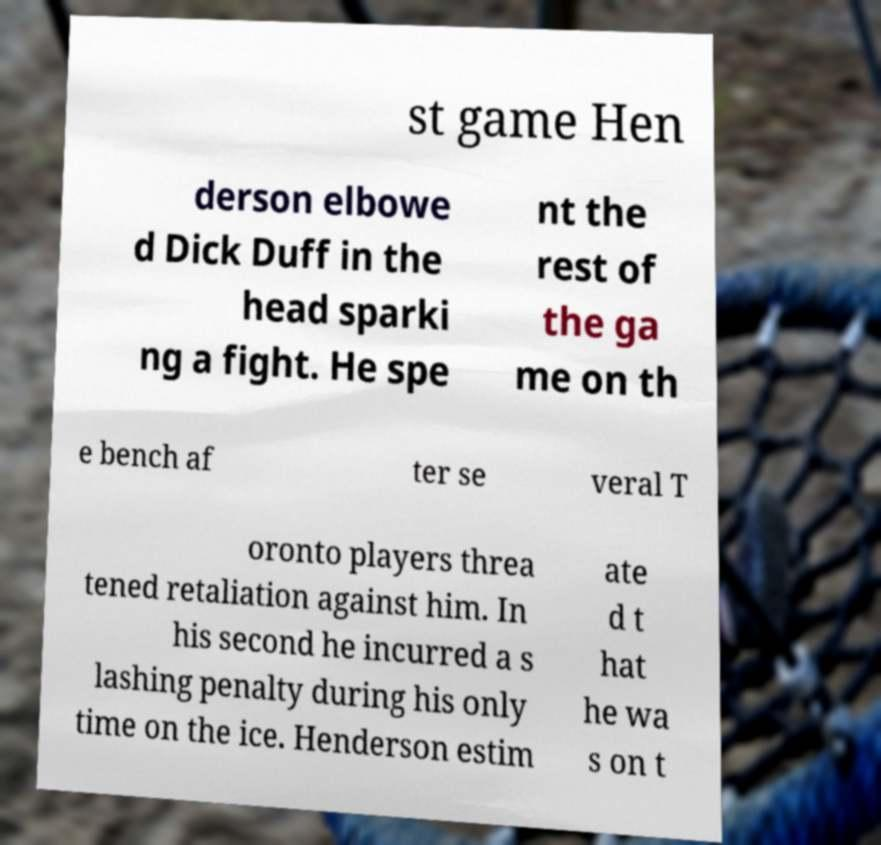Could you assist in decoding the text presented in this image and type it out clearly? st game Hen derson elbowe d Dick Duff in the head sparki ng a fight. He spe nt the rest of the ga me on th e bench af ter se veral T oronto players threa tened retaliation against him. In his second he incurred a s lashing penalty during his only time on the ice. Henderson estim ate d t hat he wa s on t 